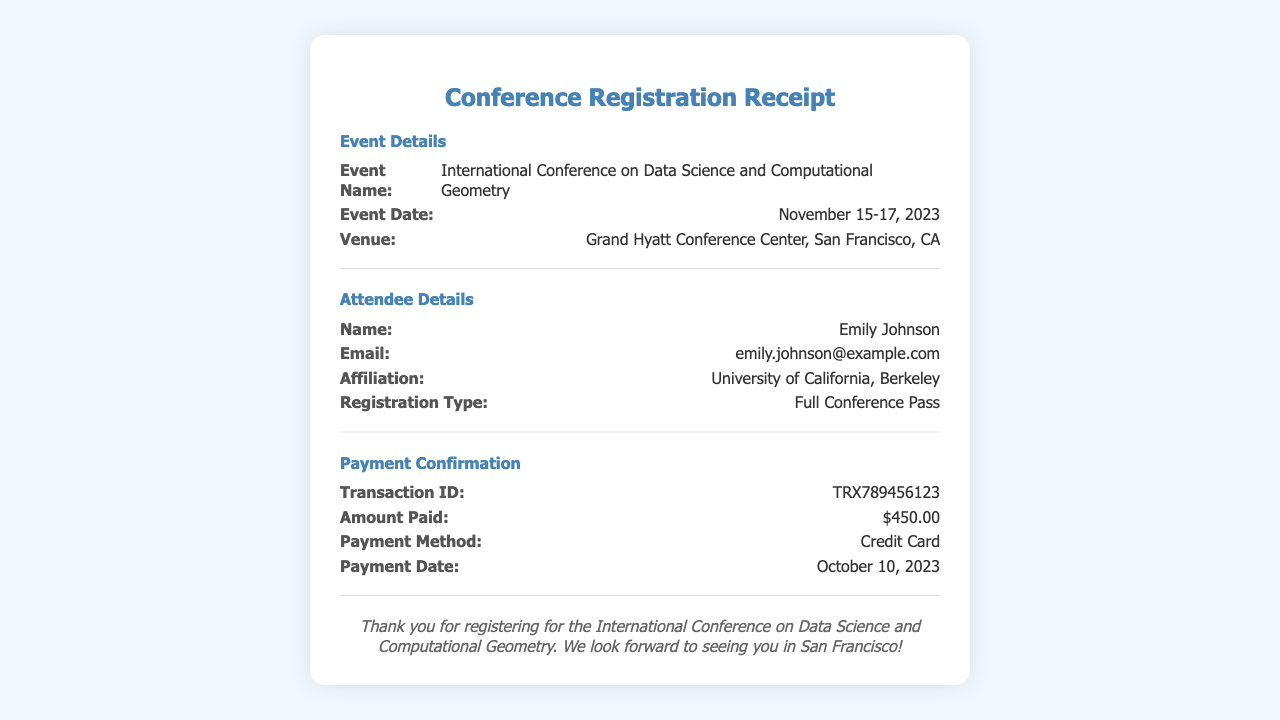What is the event name? The event name is specified under Event Details in the document.
Answer: International Conference on Data Science and Computational Geometry What are the event dates? The event dates are listed in the Event Details section.
Answer: November 15-17, 2023 Who is the attendee? The name of the attendee is provided in the Attendee Details section.
Answer: Emily Johnson What is the amount paid? The amount paid is indicated in the Payment Confirmation section of the document.
Answer: $450.00 What is the payment date? The payment date can be found in the Payment Confirmation section.
Answer: October 10, 2023 What is the venue of the conference? The venue is mentioned in the Event Details section.
Answer: Grand Hyatt Conference Center, San Francisco, CA What registration type does the attendee have? The registration type for the attendee is detailed in the Attendee Details section.
Answer: Full Conference Pass What is the transaction ID? The transaction ID is found in the Payment Confirmation section of the document.
Answer: TRX789456123 What is the email of the attendee? The email address of the attendee is specified in the Attendee Details section.
Answer: emily.johnson@example.com What is the payment method used? The payment method is mentioned in the Payment Confirmation section.
Answer: Credit Card 